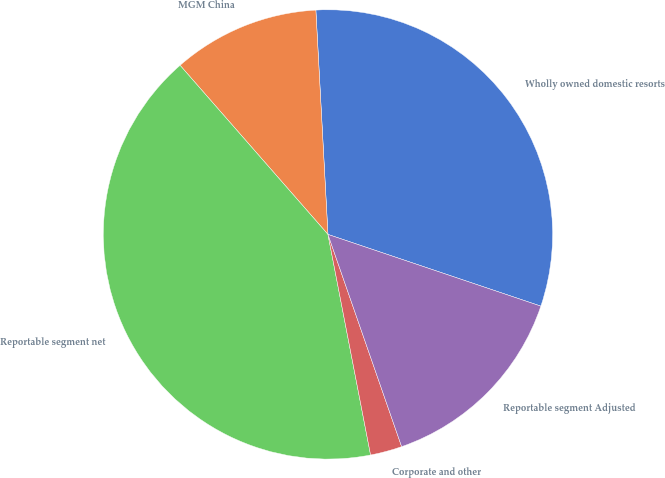Convert chart. <chart><loc_0><loc_0><loc_500><loc_500><pie_chart><fcel>Wholly owned domestic resorts<fcel>MGM China<fcel>Reportable segment net<fcel>Corporate and other<fcel>Reportable segment Adjusted<nl><fcel>31.03%<fcel>10.58%<fcel>41.6%<fcel>2.28%<fcel>14.51%<nl></chart> 